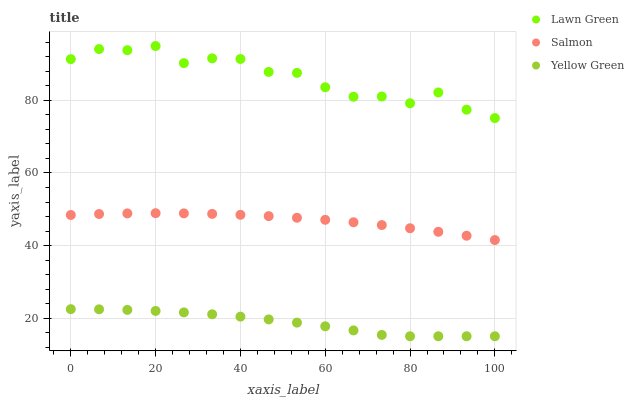Does Yellow Green have the minimum area under the curve?
Answer yes or no. Yes. Does Lawn Green have the maximum area under the curve?
Answer yes or no. Yes. Does Salmon have the minimum area under the curve?
Answer yes or no. No. Does Salmon have the maximum area under the curve?
Answer yes or no. No. Is Salmon the smoothest?
Answer yes or no. Yes. Is Lawn Green the roughest?
Answer yes or no. Yes. Is Yellow Green the smoothest?
Answer yes or no. No. Is Yellow Green the roughest?
Answer yes or no. No. Does Yellow Green have the lowest value?
Answer yes or no. Yes. Does Salmon have the lowest value?
Answer yes or no. No. Does Lawn Green have the highest value?
Answer yes or no. Yes. Does Salmon have the highest value?
Answer yes or no. No. Is Yellow Green less than Lawn Green?
Answer yes or no. Yes. Is Lawn Green greater than Salmon?
Answer yes or no. Yes. Does Yellow Green intersect Lawn Green?
Answer yes or no. No. 